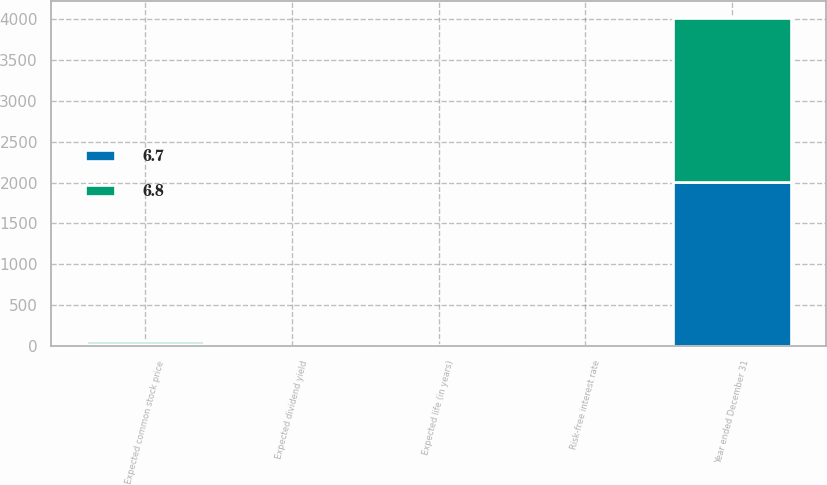Convert chart. <chart><loc_0><loc_0><loc_500><loc_500><stacked_bar_chart><ecel><fcel>Year ended December 31<fcel>Risk-free interest rate<fcel>Expected dividend yield<fcel>Expected common stock price<fcel>Expected life (in years)<nl><fcel>6.7<fcel>2006<fcel>5.11<fcel>2.89<fcel>23<fcel>6.8<nl><fcel>6.8<fcel>2004<fcel>3.44<fcel>3.59<fcel>41<fcel>6.7<nl></chart> 